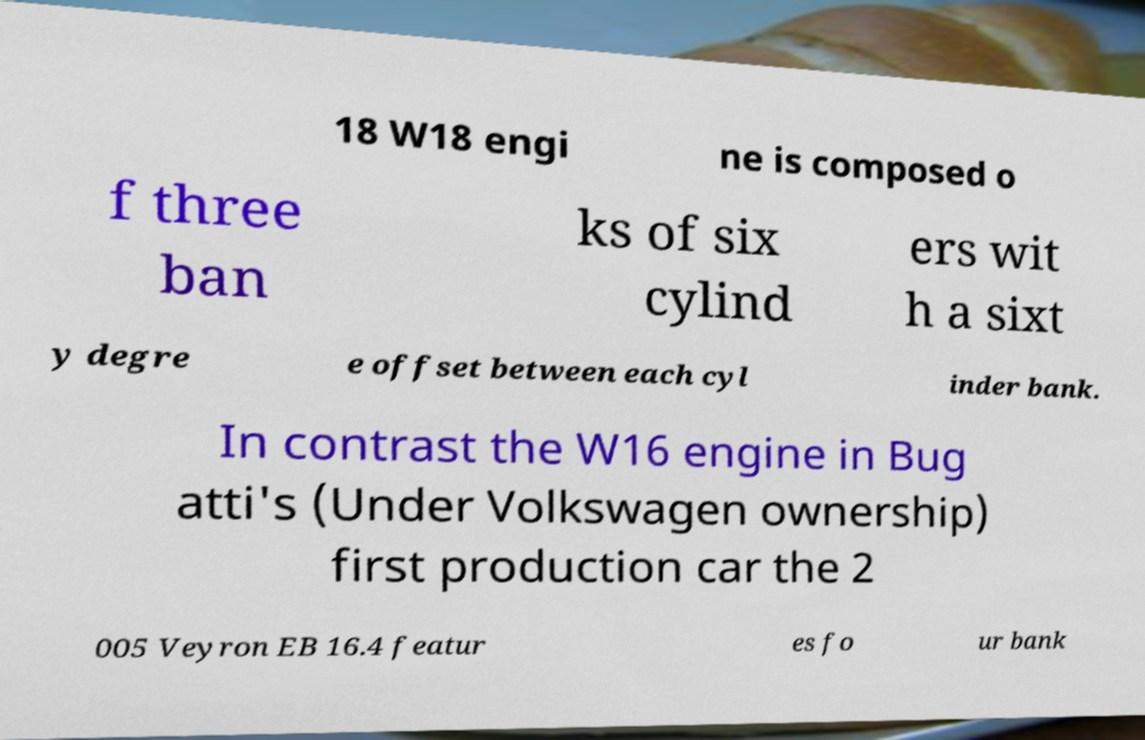Can you read and provide the text displayed in the image?This photo seems to have some interesting text. Can you extract and type it out for me? 18 W18 engi ne is composed o f three ban ks of six cylind ers wit h a sixt y degre e offset between each cyl inder bank. In contrast the W16 engine in Bug atti's (Under Volkswagen ownership) first production car the 2 005 Veyron EB 16.4 featur es fo ur bank 